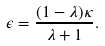<formula> <loc_0><loc_0><loc_500><loc_500>\epsilon = \frac { ( 1 - \lambda ) \kappa } { \lambda + 1 } .</formula> 